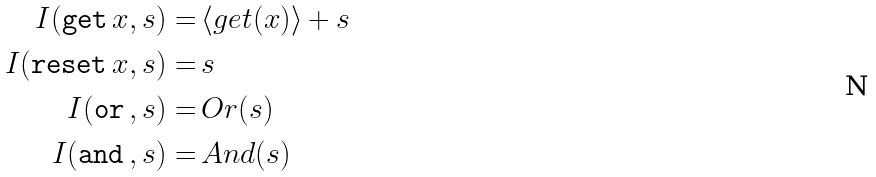<formula> <loc_0><loc_0><loc_500><loc_500>I ( { \tt g e t } \, x , s ) = & \, \langle g e t ( x ) \rangle + s \\ I ( { \tt r e s e t } \, x , s ) = & \, s \\ I ( { \tt o r } \, , s ) = & \, O r ( s ) \\ I ( { \tt a n d } \, , s ) = & \, A n d ( s )</formula> 